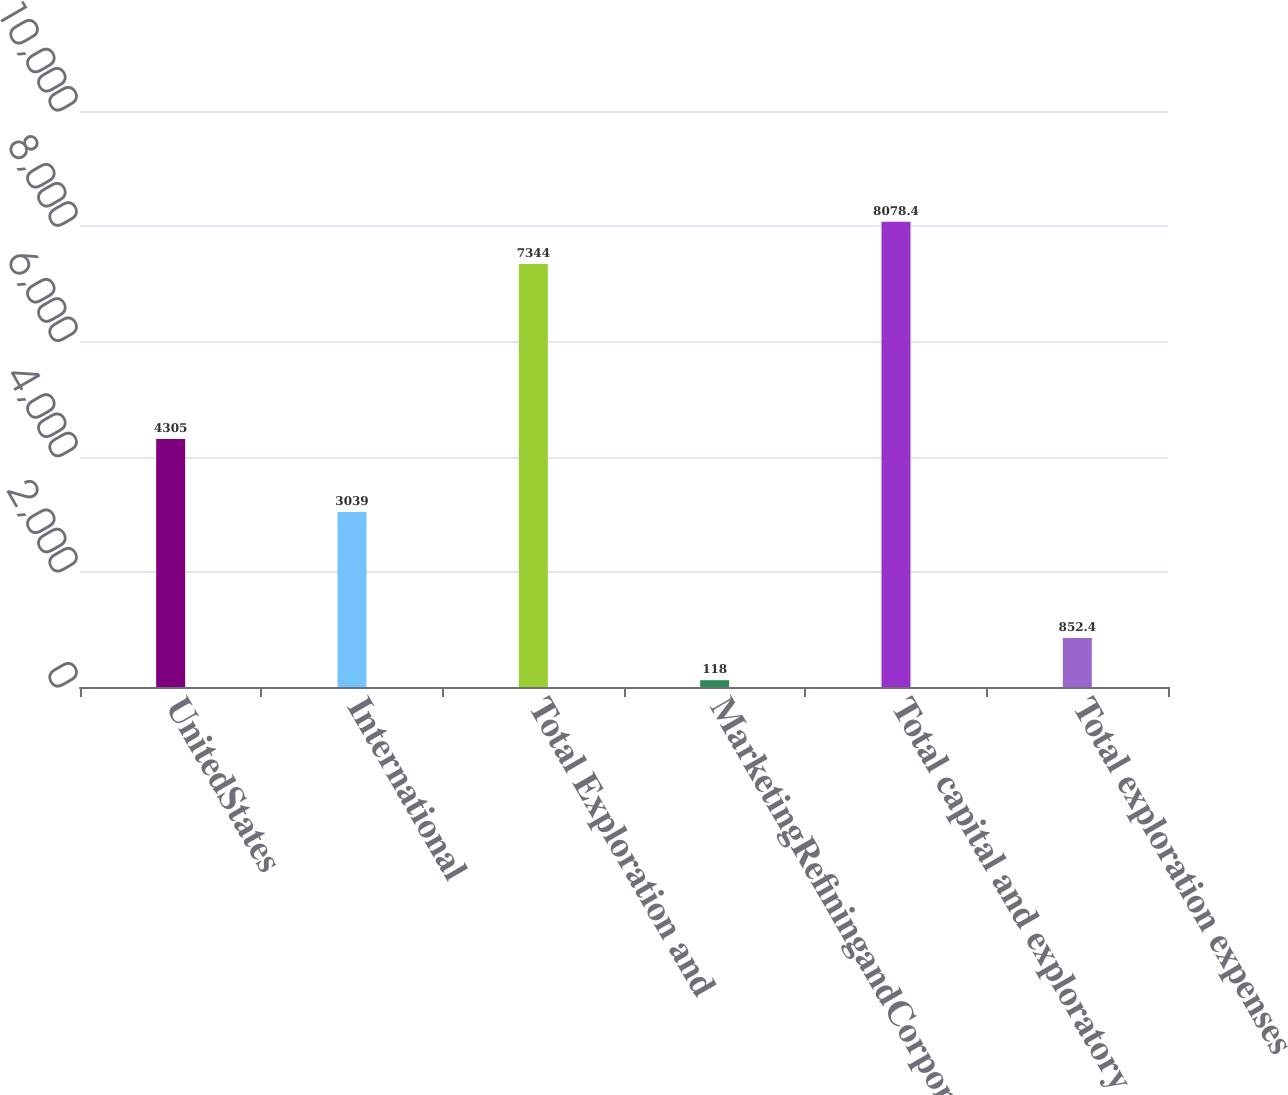<chart> <loc_0><loc_0><loc_500><loc_500><bar_chart><fcel>UnitedStates<fcel>International<fcel>Total Exploration and<fcel>MarketingRefiningandCorporate<fcel>Total capital and exploratory<fcel>Total exploration expenses<nl><fcel>4305<fcel>3039<fcel>7344<fcel>118<fcel>8078.4<fcel>852.4<nl></chart> 